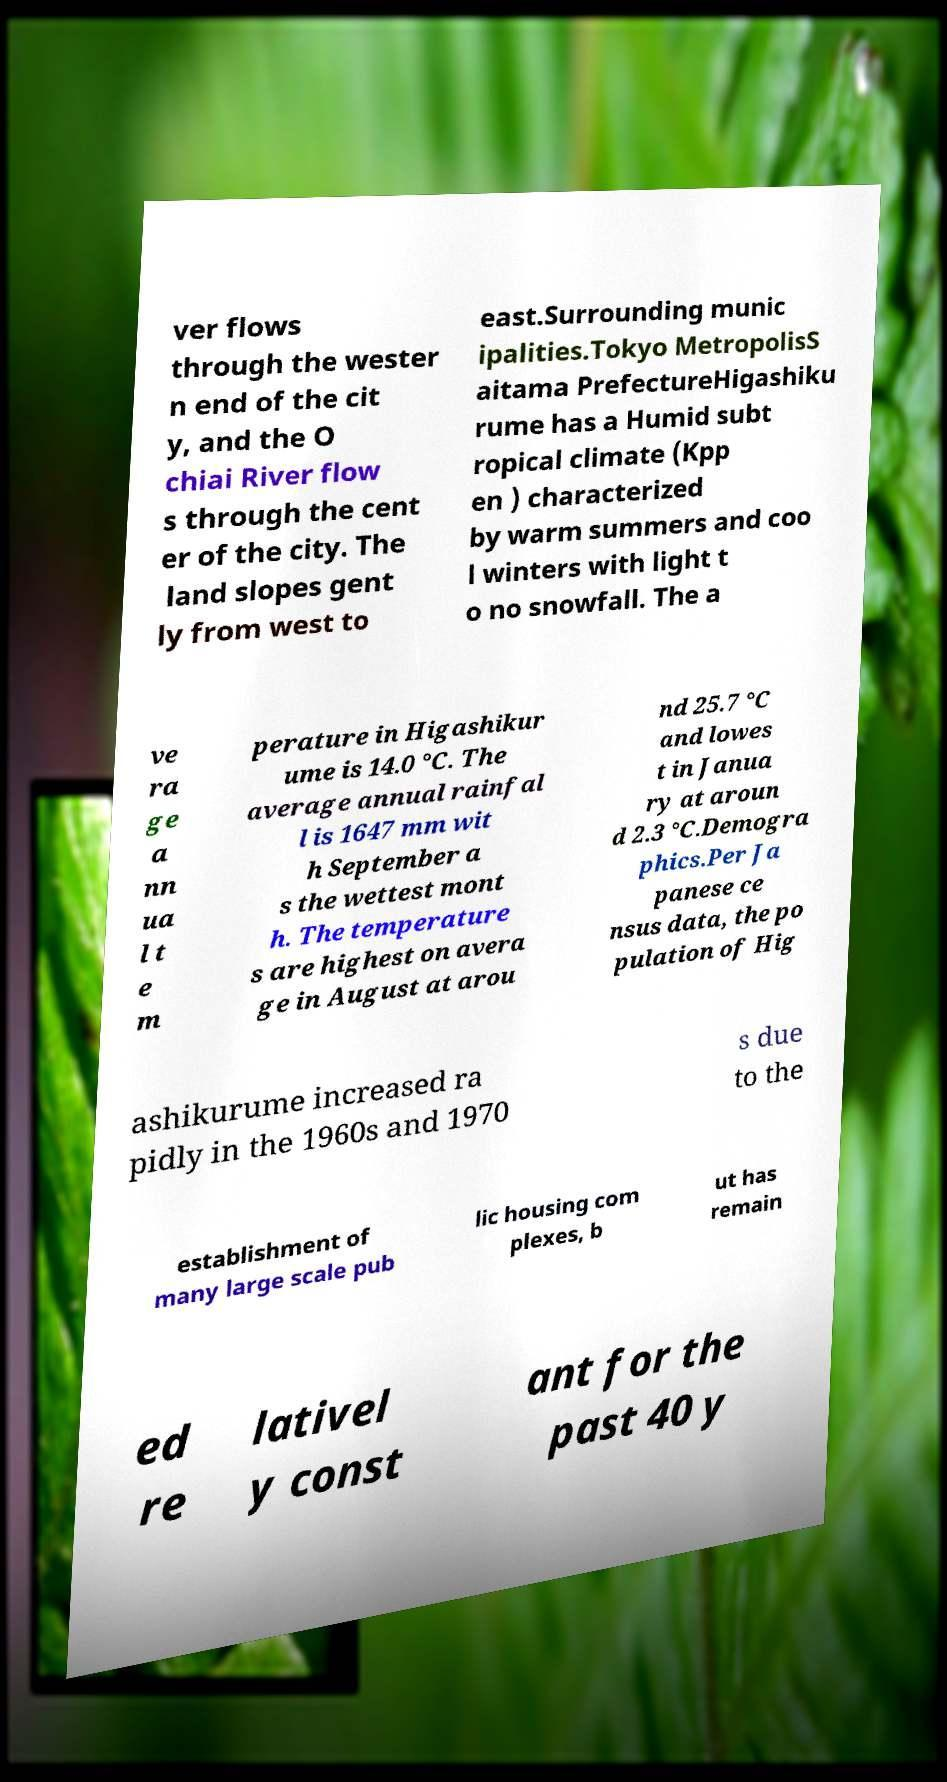There's text embedded in this image that I need extracted. Can you transcribe it verbatim? ver flows through the wester n end of the cit y, and the O chiai River flow s through the cent er of the city. The land slopes gent ly from west to east.Surrounding munic ipalities.Tokyo MetropolisS aitama PrefectureHigashiku rume has a Humid subt ropical climate (Kpp en ) characterized by warm summers and coo l winters with light t o no snowfall. The a ve ra ge a nn ua l t e m perature in Higashikur ume is 14.0 °C. The average annual rainfal l is 1647 mm wit h September a s the wettest mont h. The temperature s are highest on avera ge in August at arou nd 25.7 °C and lowes t in Janua ry at aroun d 2.3 °C.Demogra phics.Per Ja panese ce nsus data, the po pulation of Hig ashikurume increased ra pidly in the 1960s and 1970 s due to the establishment of many large scale pub lic housing com plexes, b ut has remain ed re lativel y const ant for the past 40 y 